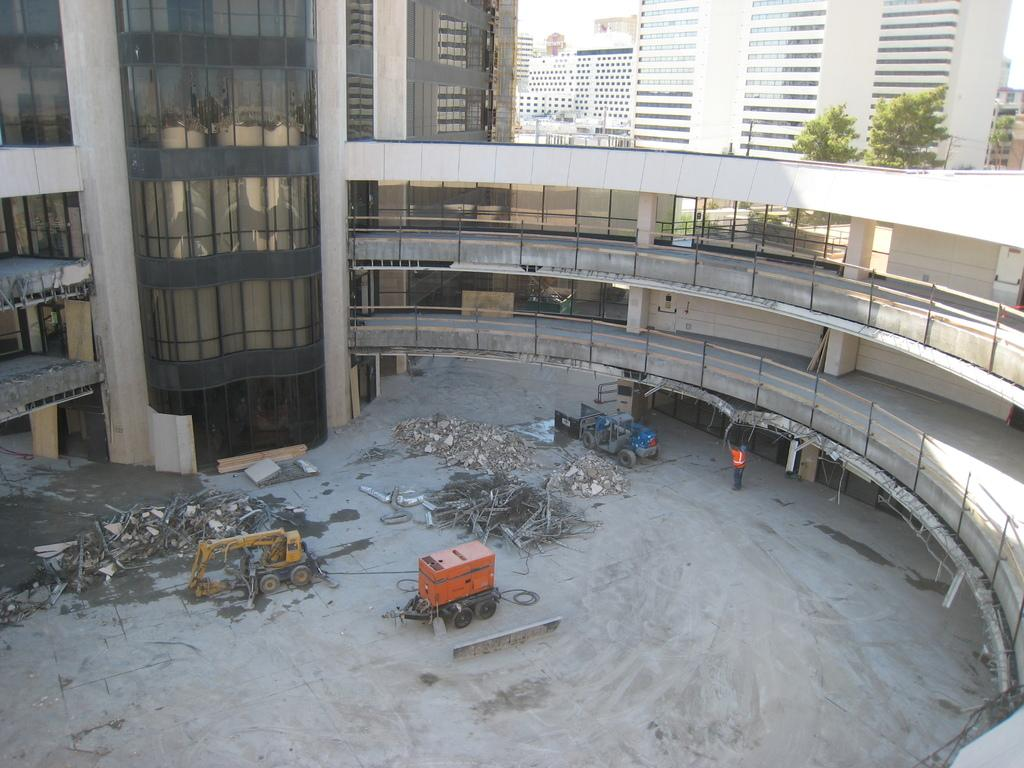What type of structures can be seen in the image? There are buildings in the image. What else can be found in the image besides buildings? There are trees and vehicles in the image. Are there any objects on the ground in the image? Yes, there are objects on the ground in the image. How many brains can be seen in the image? There are no brains visible in the image. What time is displayed on the clock in the image? There is no clock present in the image. 